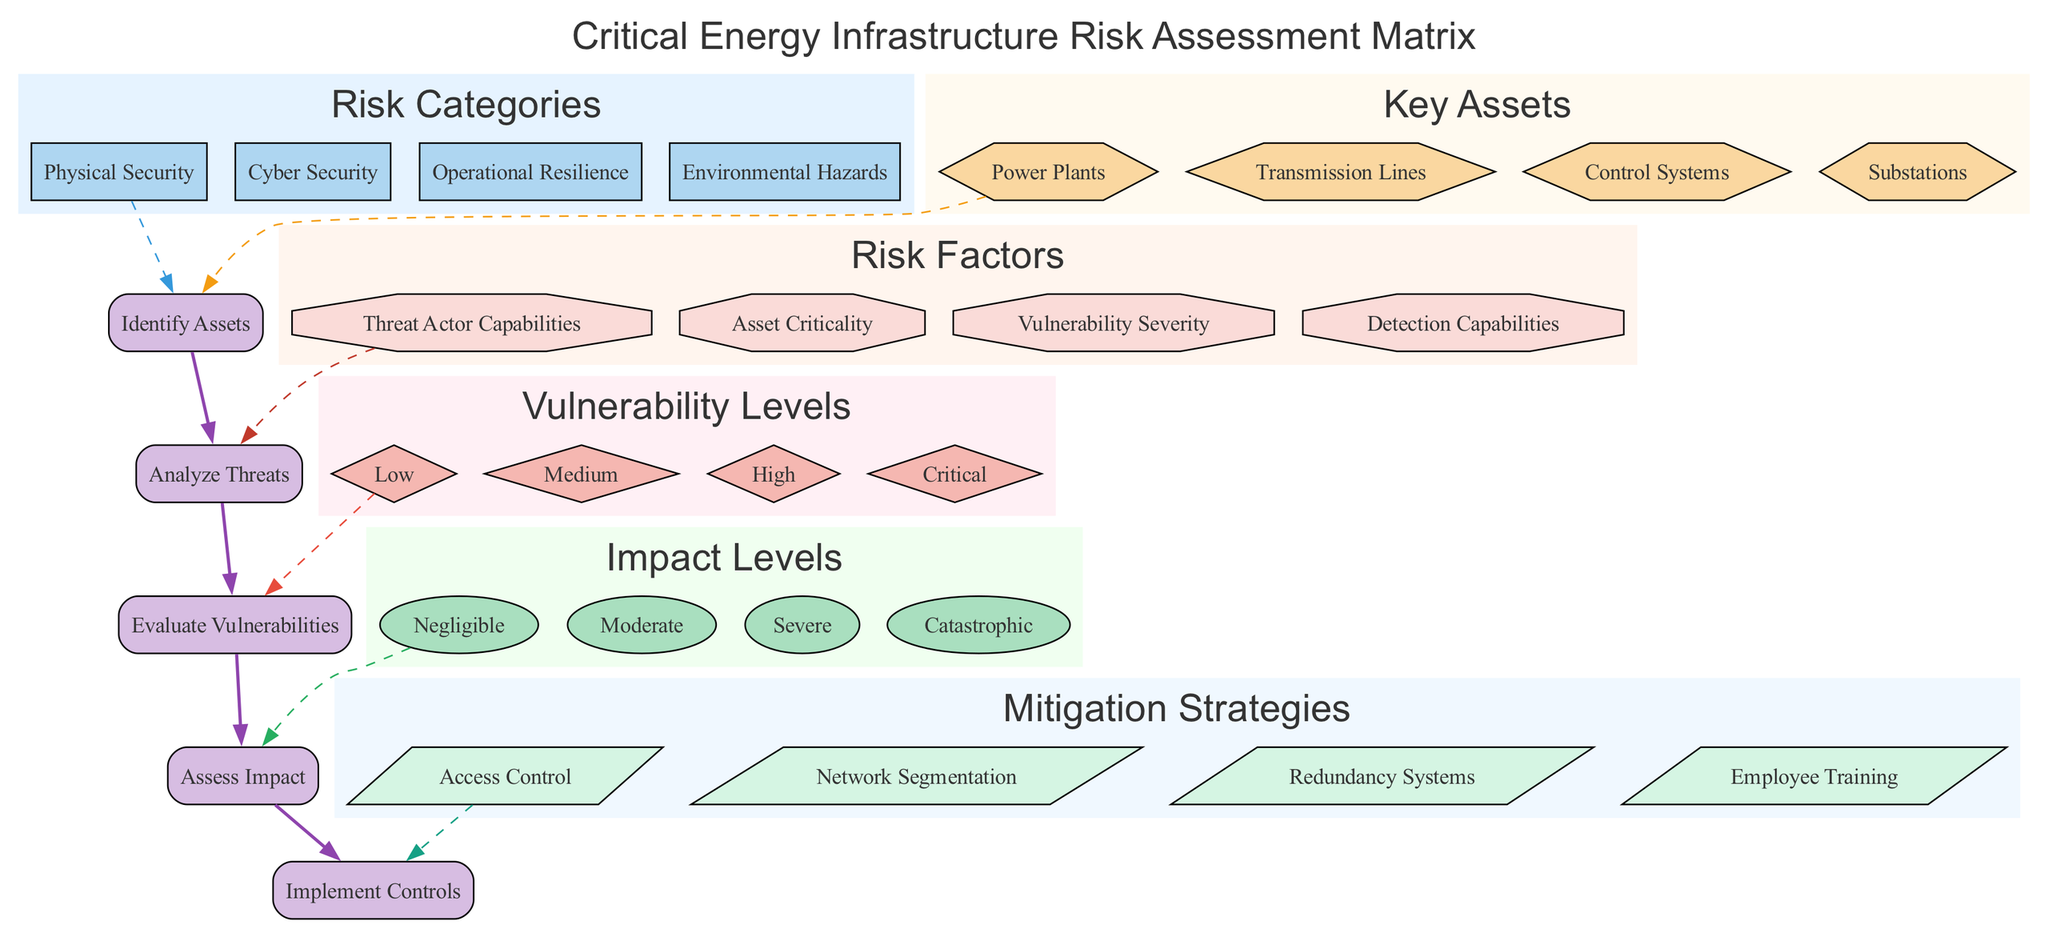What are the four risk categories represented in the diagram? The diagram lists the risk categories under the "Risk Categories" section. Upon examining the nodes, we find the categories: Physical Security, Cyber Security, Operational Resilience, and Environmental Hazards.
Answer: Physical Security, Cyber Security, Operational Resilience, Environmental Hazards What shape represents the impact levels in the matrix? The shape corresponding to impact levels is identified by checking the "Impact Levels" subgraph. Each node representing impact levels is shaped like an oval, as highlighted in the diagram.
Answer: Oval How many key assets are identified in the matrix? By counting the nodes in the "Key Assets" section, we find that there are four represented assets: Power Plants, Transmission Lines, Control Systems, and Substations. This provides a total of four key assets.
Answer: Four Which mitigation strategy is connected to the last assessment step? The final assessment step in the "Assessment Steps" section is "Implement Controls." From inspecting the edges, we see that the first mitigation strategy, "Access Control," is connected to the last assessment step, indicating the flow of the diagram.
Answer: Access Control What is the relationship between "Vulnerability Severity" and "Analyze Threats"? In the diagram, "Vulnerability Severity" is represented under "Risk Factors." The edge connecting "Vulnerability Severity" to the assessment step "Analyze Threats" indicates that analyzing vulnerabilities is directly influenced by understanding severity, showing a flow from factors to assessment steps.
Answer: Analyze Threats Which risk factor has the potential to influence the impact assessment? "Asset Criticality," found under "Risk Factors," has an edge leading to the assessment step "Assess Impact." This suggests that understanding the criticality of assets is key when evaluating impact levels within the infrastructure risk assessment.
Answer: Asset Criticality What color represents the "Mitigation Strategies" cluster in the diagram? The "Mitigation Strategies" cluster has a light blue color, indicated directly in the diagram. By observing the cluster's attribute, we can identify it as light blue filling.
Answer: Light blue What is the first step of the assessment process in the diagram? The assessment steps are arranged sequentially, and the first step identified at the top of the "Assessment Steps" section is "Identify Assets." This order confirms its position as the initial step in the risk assessment process.
Answer: Identify Assets 